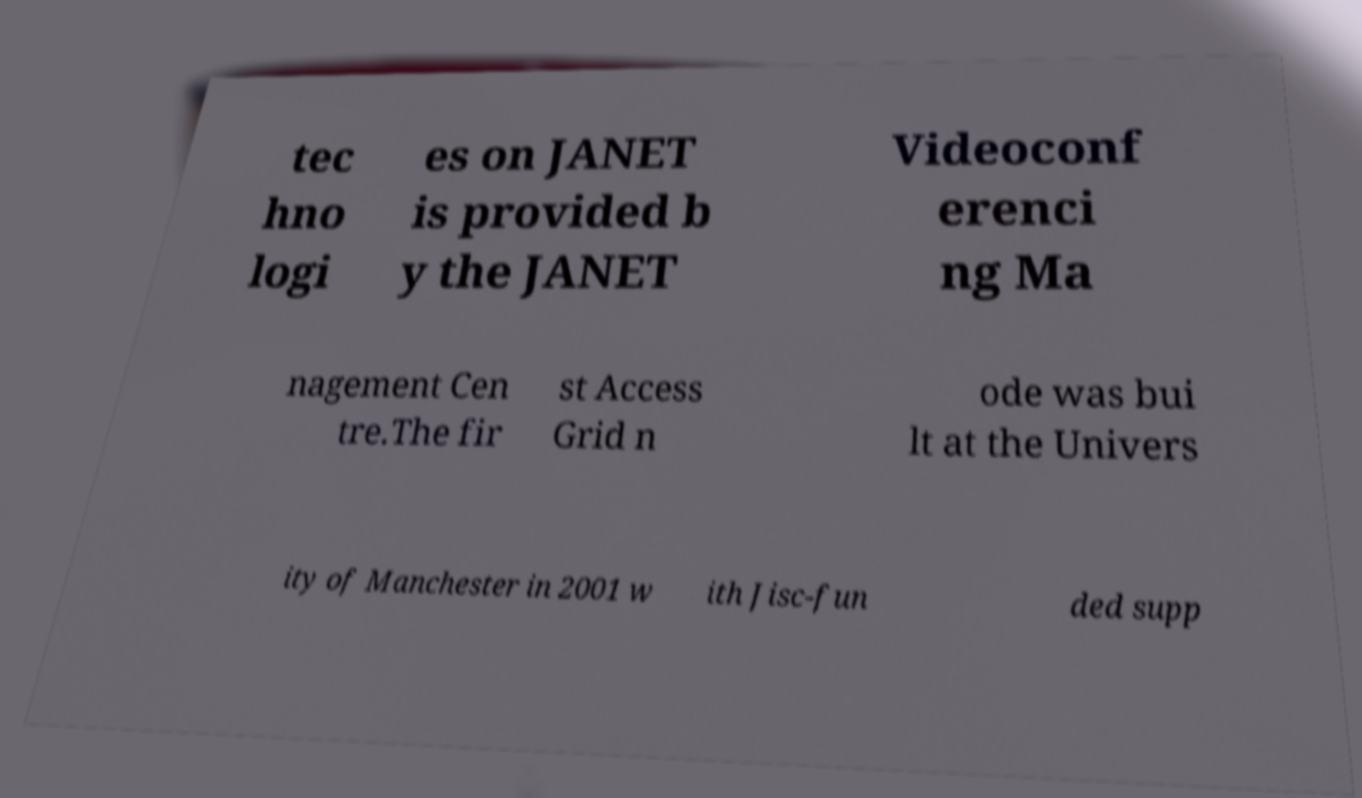Can you accurately transcribe the text from the provided image for me? tec hno logi es on JANET is provided b y the JANET Videoconf erenci ng Ma nagement Cen tre.The fir st Access Grid n ode was bui lt at the Univers ity of Manchester in 2001 w ith Jisc-fun ded supp 